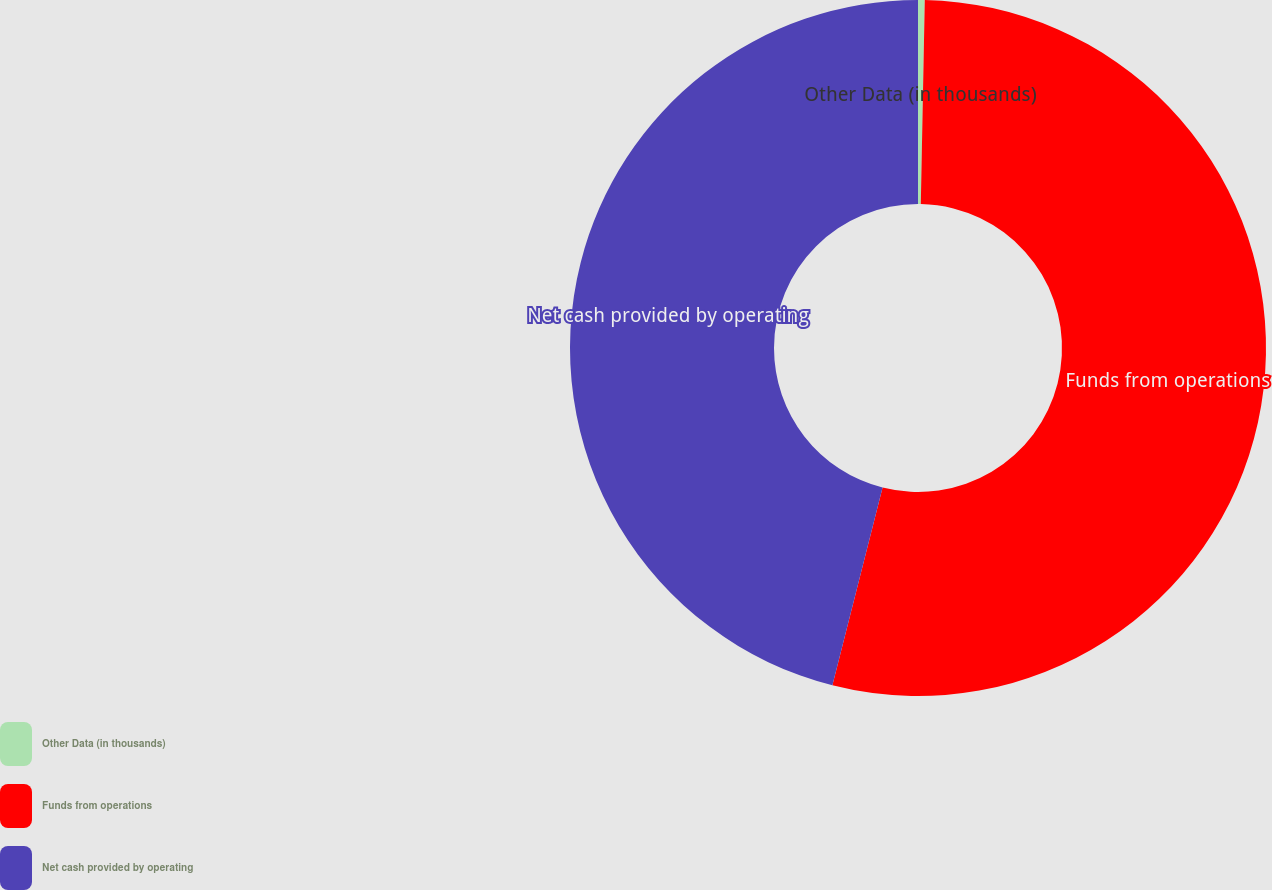Convert chart. <chart><loc_0><loc_0><loc_500><loc_500><pie_chart><fcel>Other Data (in thousands)<fcel>Funds from operations<fcel>Net cash provided by operating<nl><fcel>0.31%<fcel>53.64%<fcel>46.04%<nl></chart> 